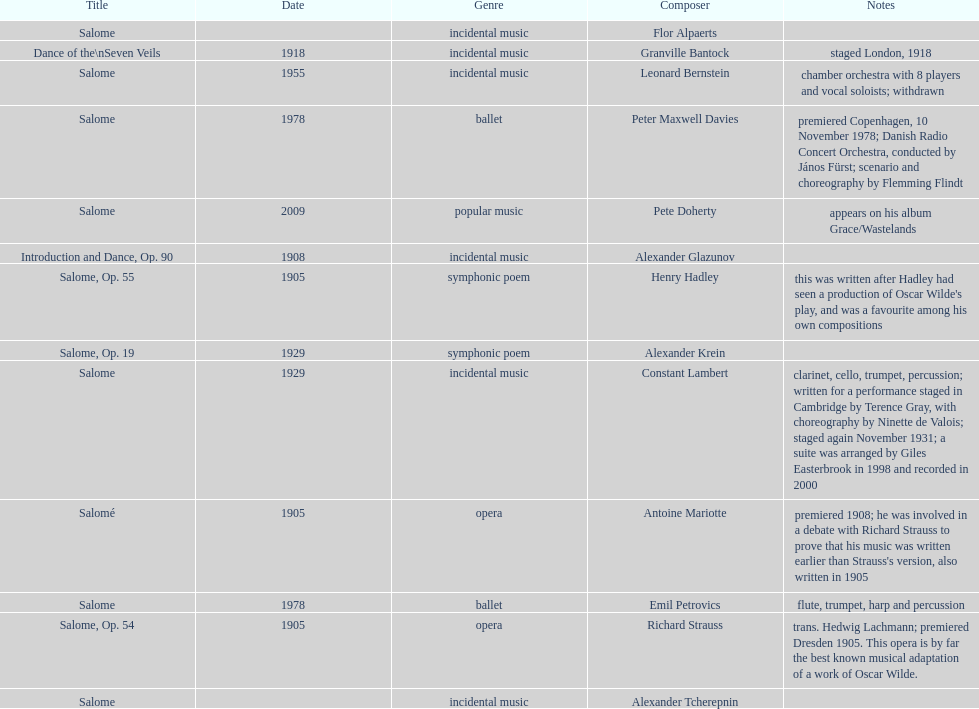What is the difference in years of granville bantock's work compared to pete dohert? 91. Write the full table. {'header': ['Title', 'Date', 'Genre', 'Composer', 'Notes'], 'rows': [['Salome', '', 'incidental\xa0music', 'Flor Alpaerts', ''], ['Dance of the\\nSeven Veils', '1918', 'incidental music', 'Granville Bantock', 'staged London, 1918'], ['Salome', '1955', 'incidental music', 'Leonard Bernstein', 'chamber orchestra with 8 players and vocal soloists; withdrawn'], ['Salome', '1978', 'ballet', 'Peter\xa0Maxwell\xa0Davies', 'premiered Copenhagen, 10 November 1978; Danish Radio Concert Orchestra, conducted by János Fürst; scenario and choreography by Flemming Flindt'], ['Salome', '2009', 'popular music', 'Pete Doherty', 'appears on his album Grace/Wastelands'], ['Introduction and Dance, Op. 90', '1908', 'incidental music', 'Alexander Glazunov', ''], ['Salome, Op. 55', '1905', 'symphonic poem', 'Henry Hadley', "this was written after Hadley had seen a production of Oscar Wilde's play, and was a favourite among his own compositions"], ['Salome, Op. 19', '1929', 'symphonic poem', 'Alexander Krein', ''], ['Salome', '1929', 'incidental music', 'Constant Lambert', 'clarinet, cello, trumpet, percussion; written for a performance staged in Cambridge by Terence Gray, with choreography by Ninette de Valois; staged again November 1931; a suite was arranged by Giles Easterbrook in 1998 and recorded in 2000'], ['Salomé', '1905', 'opera', 'Antoine Mariotte', "premiered 1908; he was involved in a debate with Richard Strauss to prove that his music was written earlier than Strauss's version, also written in 1905"], ['Salome', '1978', 'ballet', 'Emil Petrovics', 'flute, trumpet, harp and percussion'], ['Salome, Op. 54', '1905', 'opera', 'Richard Strauss', 'trans. Hedwig Lachmann; premiered Dresden 1905. This opera is by far the best known musical adaptation of a work of Oscar Wilde.'], ['Salome', '', 'incidental music', 'Alexander\xa0Tcherepnin', '']]} 